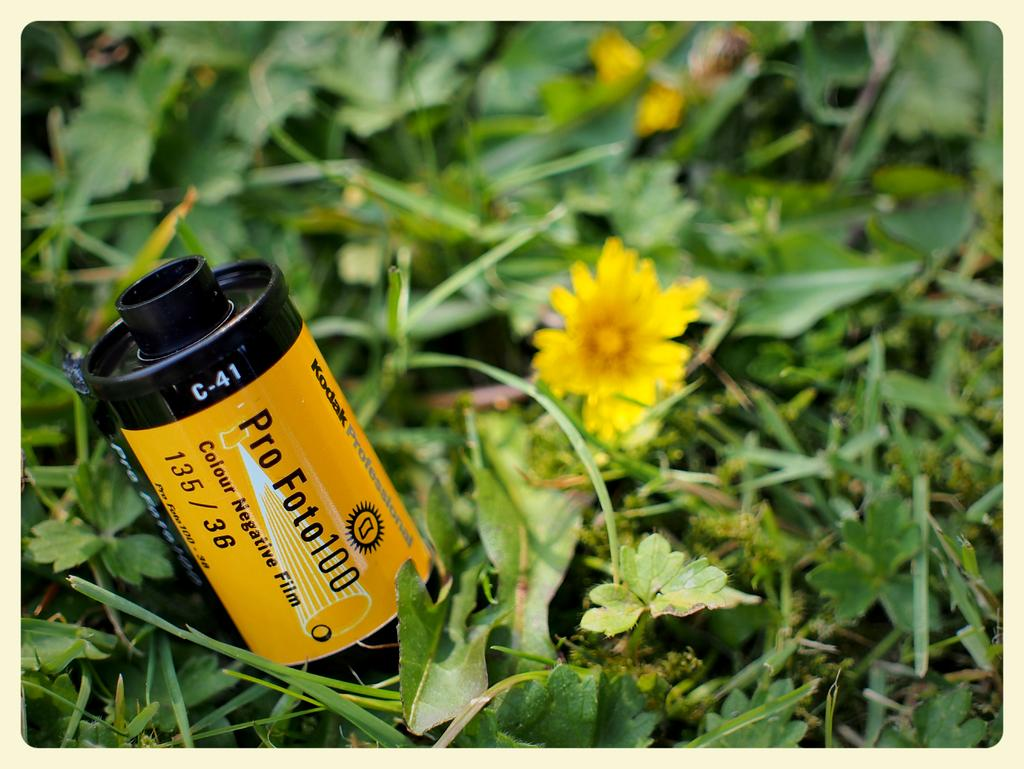What object is present in the image that is used for storing photos? There is a photo reel in the image. Where is the photo reel located? The photo reel is on the land. What type of vegetation can be seen in the image? There are plants in the image. Can you describe a specific type of flowering plant in the image? There is a yellow color flower plant in the image. What type of patch is used to repair the photo reel in the image? There is no patch visible in the image, nor is there any indication that the photo reel needs repair. --- Facts: 1. There is a person holding a book in the image. 2. The person is sitting on a chair. 3. The chair is made of wood. 4. The book has a blue cover. Absurd Topics: parrot, ocean, dance Conversation: What is the person in the image holding? The person is holding a book in the image. What is the person's position in the image? The person is sitting on a chair. What material is the chair made of? The chair is made of wood. What color is the book's cover? The book has a blue cover. Reasoning: Let's think step by step in order to produce the conversation. We start by identifying the main subject in the image, which is the person holding a book. Then, we describe the person's position, which is sitting on a chair. Next, we mention the material of the chair, which is wood. Finally, we provide a specific detail about the book, which is its blue cover. Absurd Question/Answer: Can you see a parrot dancing in the ocean in the image? There is no parrot or ocean present in the image; it features a person sitting on a wooden chair holding a book with a blue cover. 